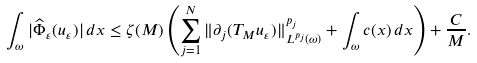<formula> <loc_0><loc_0><loc_500><loc_500>\int _ { \omega } | \widehat { \Phi } _ { \varepsilon } ( u _ { \varepsilon } ) | \, d x \leq \zeta ( M ) \left ( \sum _ { j = 1 } ^ { N } \| \partial _ { j } ( T _ { M } u _ { \varepsilon } ) \| ^ { p _ { j } } _ { L ^ { p _ { j } } ( \omega ) } + \int _ { \omega } c ( x ) \, d x \right ) + \frac { C } { M } .</formula> 